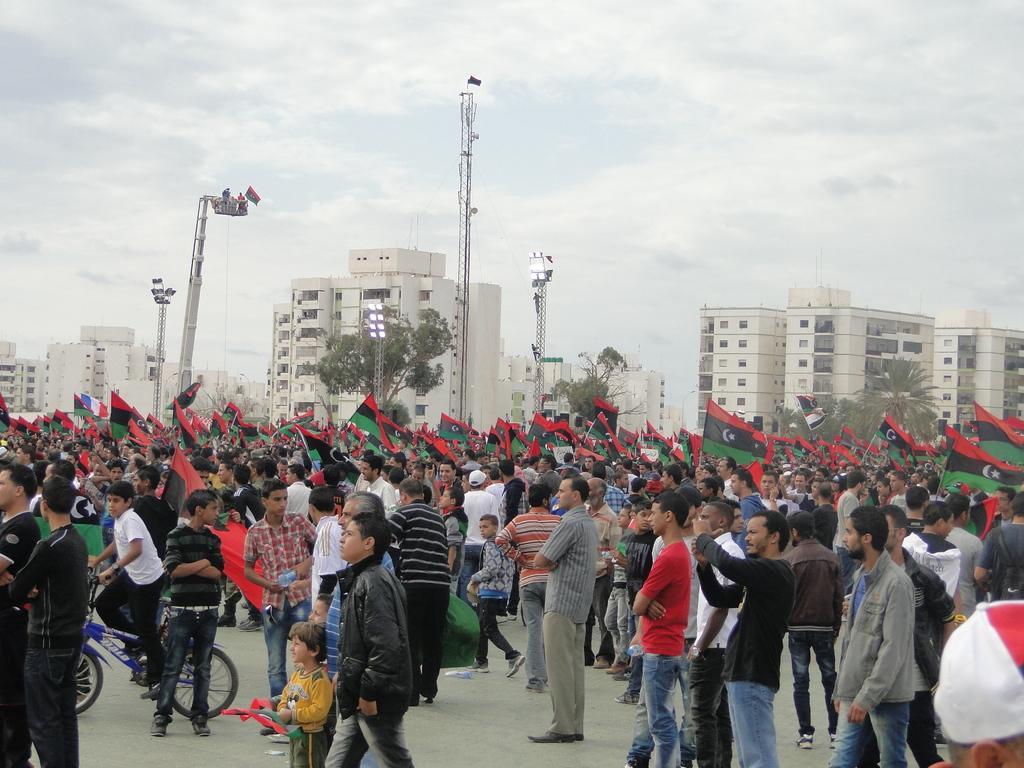Can you describe this image briefly? In this image I can see group of people holding flags. Flag is in red,black,white and green color. I can see a person is on the bicycle. Back I can see buildings,trees,light-poles and cranes. The sky is in blue and white color. 